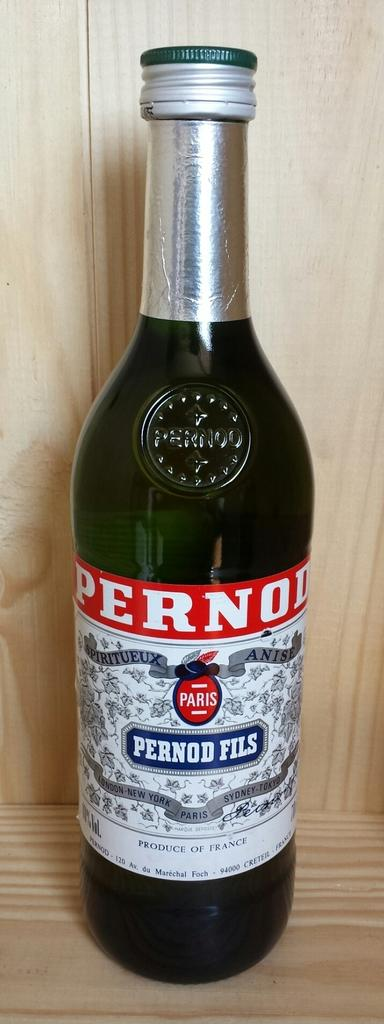<image>
Present a compact description of the photo's key features. A bottle of Pernod Fils from Paris is on a wooden shelf. 